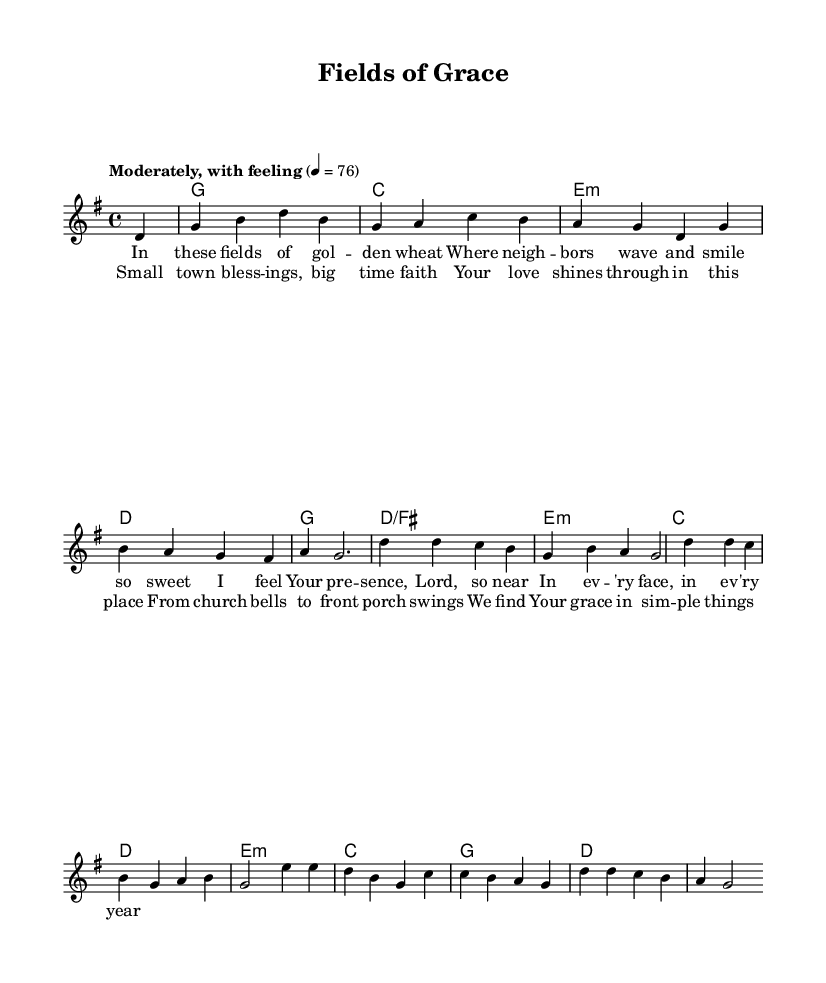What is the key signature of this music? The key signature is indicated at the beginning of the piece. It shows one sharp, which is characteristic of G major.
Answer: G major What is the time signature of this music? The time signature is found at the beginning of the score, represented as "4/4", which indicates four beats per measure.
Answer: 4/4 What is the tempo marking for this piece? The tempo marking is given in the score as "Moderately, with feeling" followed by "4 = 76", indicating a moderate tempo of 76 beats per minute.
Answer: Moderately, with feeling How many verses are present in the lyrics section? By examining the lyrics set to the melody, we can find that there is one verse before the chorus, denoted in the score.
Answer: One What is the primary theme expressed in the lyrics? The lyrics reflect small-town life and the presence of God's grace in everyday experiences, which is evident from phrases like "small town blessings" and "we find Your grace in simple things."
Answer: Small-town life and God's grace What musical form is this song structured in? The song is structured in a verse-chorus format, as seen from the presence of a verse (first section) followed by a chorus (repeated section).
Answer: Verse-chorus What type of harmony is primarily used in this piece? The harmony involves diatonic chords that are built from the notes of the G major scale, which is common in contemporary Christian music and is evident in the progression shown in the score.
Answer: Diatonic chords 